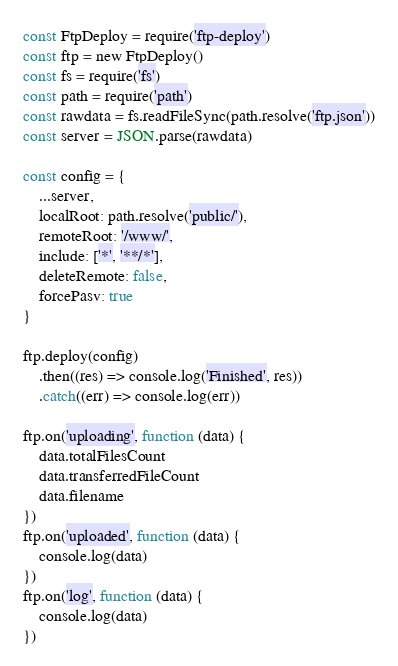Convert code to text. <code><loc_0><loc_0><loc_500><loc_500><_JavaScript_>const FtpDeploy = require('ftp-deploy')
const ftp = new FtpDeploy()
const fs = require('fs')
const path = require('path')
const rawdata = fs.readFileSync(path.resolve('ftp.json'))
const server = JSON.parse(rawdata)

const config = {
    ...server,
    localRoot: path.resolve('public/'),
    remoteRoot: '/www/',
    include: ['*', '**/*'],
    deleteRemote: false,
    forcePasv: true
}

ftp.deploy(config)
    .then((res) => console.log('Finished', res))
    .catch((err) => console.log(err))

ftp.on('uploading', function (data) {
    data.totalFilesCount
    data.transferredFileCount
    data.filename
})
ftp.on('uploaded', function (data) {
    console.log(data)
})
ftp.on('log', function (data) {
    console.log(data)
})
</code> 